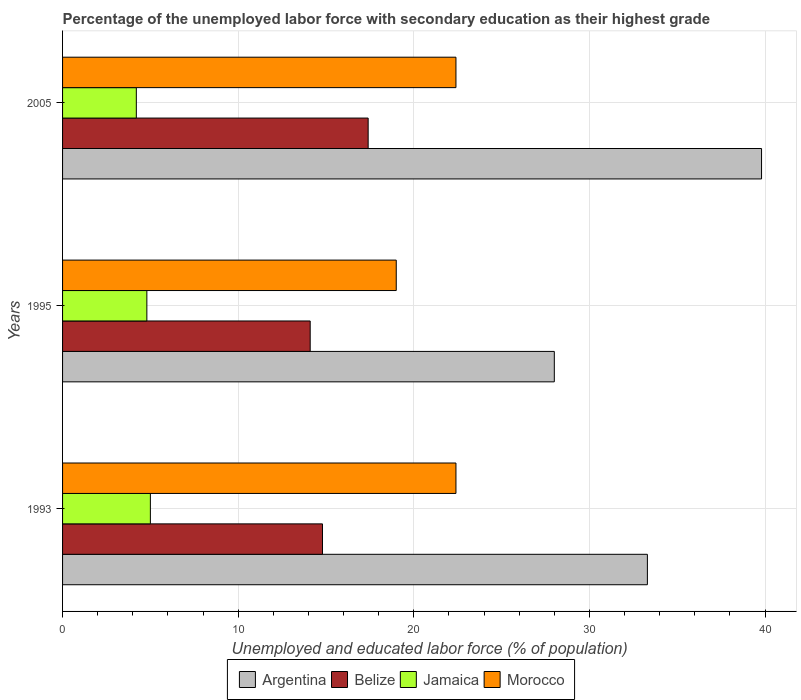How many different coloured bars are there?
Your answer should be very brief. 4. How many groups of bars are there?
Your answer should be very brief. 3. In how many cases, is the number of bars for a given year not equal to the number of legend labels?
Offer a very short reply. 0. What is the percentage of the unemployed labor force with secondary education in Argentina in 2005?
Offer a very short reply. 39.8. Across all years, what is the maximum percentage of the unemployed labor force with secondary education in Argentina?
Your answer should be compact. 39.8. Across all years, what is the minimum percentage of the unemployed labor force with secondary education in Belize?
Provide a short and direct response. 14.1. In which year was the percentage of the unemployed labor force with secondary education in Morocco maximum?
Offer a terse response. 1993. What is the total percentage of the unemployed labor force with secondary education in Morocco in the graph?
Give a very brief answer. 63.8. What is the difference between the percentage of the unemployed labor force with secondary education in Belize in 1995 and that in 2005?
Your answer should be very brief. -3.3. What is the difference between the percentage of the unemployed labor force with secondary education in Jamaica in 1993 and the percentage of the unemployed labor force with secondary education in Belize in 1995?
Ensure brevity in your answer.  -9.1. What is the average percentage of the unemployed labor force with secondary education in Jamaica per year?
Your response must be concise. 4.67. In the year 1993, what is the difference between the percentage of the unemployed labor force with secondary education in Jamaica and percentage of the unemployed labor force with secondary education in Morocco?
Give a very brief answer. -17.4. What is the difference between the highest and the second highest percentage of the unemployed labor force with secondary education in Jamaica?
Keep it short and to the point. 0.2. What is the difference between the highest and the lowest percentage of the unemployed labor force with secondary education in Belize?
Your answer should be very brief. 3.3. In how many years, is the percentage of the unemployed labor force with secondary education in Argentina greater than the average percentage of the unemployed labor force with secondary education in Argentina taken over all years?
Provide a short and direct response. 1. Is the sum of the percentage of the unemployed labor force with secondary education in Belize in 1993 and 1995 greater than the maximum percentage of the unemployed labor force with secondary education in Argentina across all years?
Give a very brief answer. No. Is it the case that in every year, the sum of the percentage of the unemployed labor force with secondary education in Morocco and percentage of the unemployed labor force with secondary education in Belize is greater than the sum of percentage of the unemployed labor force with secondary education in Jamaica and percentage of the unemployed labor force with secondary education in Argentina?
Provide a short and direct response. No. What does the 3rd bar from the top in 2005 represents?
Offer a very short reply. Belize. What does the 3rd bar from the bottom in 2005 represents?
Offer a very short reply. Jamaica. Is it the case that in every year, the sum of the percentage of the unemployed labor force with secondary education in Morocco and percentage of the unemployed labor force with secondary education in Belize is greater than the percentage of the unemployed labor force with secondary education in Argentina?
Offer a very short reply. Yes. How many years are there in the graph?
Provide a short and direct response. 3. What is the difference between two consecutive major ticks on the X-axis?
Offer a terse response. 10. What is the title of the graph?
Your response must be concise. Percentage of the unemployed labor force with secondary education as their highest grade. Does "Mongolia" appear as one of the legend labels in the graph?
Keep it short and to the point. No. What is the label or title of the X-axis?
Your answer should be compact. Unemployed and educated labor force (% of population). What is the Unemployed and educated labor force (% of population) of Argentina in 1993?
Keep it short and to the point. 33.3. What is the Unemployed and educated labor force (% of population) of Belize in 1993?
Provide a succinct answer. 14.8. What is the Unemployed and educated labor force (% of population) in Jamaica in 1993?
Make the answer very short. 5. What is the Unemployed and educated labor force (% of population) of Morocco in 1993?
Offer a terse response. 22.4. What is the Unemployed and educated labor force (% of population) in Argentina in 1995?
Your answer should be very brief. 28. What is the Unemployed and educated labor force (% of population) of Belize in 1995?
Give a very brief answer. 14.1. What is the Unemployed and educated labor force (% of population) in Jamaica in 1995?
Ensure brevity in your answer.  4.8. What is the Unemployed and educated labor force (% of population) in Morocco in 1995?
Give a very brief answer. 19. What is the Unemployed and educated labor force (% of population) of Argentina in 2005?
Give a very brief answer. 39.8. What is the Unemployed and educated labor force (% of population) in Belize in 2005?
Provide a succinct answer. 17.4. What is the Unemployed and educated labor force (% of population) in Jamaica in 2005?
Your answer should be compact. 4.2. What is the Unemployed and educated labor force (% of population) in Morocco in 2005?
Keep it short and to the point. 22.4. Across all years, what is the maximum Unemployed and educated labor force (% of population) in Argentina?
Provide a succinct answer. 39.8. Across all years, what is the maximum Unemployed and educated labor force (% of population) of Belize?
Offer a terse response. 17.4. Across all years, what is the maximum Unemployed and educated labor force (% of population) of Jamaica?
Ensure brevity in your answer.  5. Across all years, what is the maximum Unemployed and educated labor force (% of population) in Morocco?
Provide a succinct answer. 22.4. Across all years, what is the minimum Unemployed and educated labor force (% of population) of Argentina?
Ensure brevity in your answer.  28. Across all years, what is the minimum Unemployed and educated labor force (% of population) in Belize?
Provide a short and direct response. 14.1. Across all years, what is the minimum Unemployed and educated labor force (% of population) of Jamaica?
Keep it short and to the point. 4.2. Across all years, what is the minimum Unemployed and educated labor force (% of population) of Morocco?
Provide a short and direct response. 19. What is the total Unemployed and educated labor force (% of population) of Argentina in the graph?
Make the answer very short. 101.1. What is the total Unemployed and educated labor force (% of population) in Belize in the graph?
Offer a very short reply. 46.3. What is the total Unemployed and educated labor force (% of population) of Morocco in the graph?
Offer a terse response. 63.8. What is the difference between the Unemployed and educated labor force (% of population) of Argentina in 1993 and that in 1995?
Make the answer very short. 5.3. What is the difference between the Unemployed and educated labor force (% of population) of Argentina in 1993 and that in 2005?
Provide a succinct answer. -6.5. What is the difference between the Unemployed and educated labor force (% of population) in Belize in 1993 and that in 2005?
Offer a terse response. -2.6. What is the difference between the Unemployed and educated labor force (% of population) of Belize in 1995 and that in 2005?
Make the answer very short. -3.3. What is the difference between the Unemployed and educated labor force (% of population) in Jamaica in 1995 and that in 2005?
Make the answer very short. 0.6. What is the difference between the Unemployed and educated labor force (% of population) in Morocco in 1995 and that in 2005?
Your answer should be compact. -3.4. What is the difference between the Unemployed and educated labor force (% of population) in Argentina in 1993 and the Unemployed and educated labor force (% of population) in Belize in 1995?
Your answer should be very brief. 19.2. What is the difference between the Unemployed and educated labor force (% of population) in Argentina in 1993 and the Unemployed and educated labor force (% of population) in Jamaica in 1995?
Give a very brief answer. 28.5. What is the difference between the Unemployed and educated labor force (% of population) in Belize in 1993 and the Unemployed and educated labor force (% of population) in Morocco in 1995?
Provide a short and direct response. -4.2. What is the difference between the Unemployed and educated labor force (% of population) in Jamaica in 1993 and the Unemployed and educated labor force (% of population) in Morocco in 1995?
Your answer should be very brief. -14. What is the difference between the Unemployed and educated labor force (% of population) in Argentina in 1993 and the Unemployed and educated labor force (% of population) in Belize in 2005?
Offer a very short reply. 15.9. What is the difference between the Unemployed and educated labor force (% of population) of Argentina in 1993 and the Unemployed and educated labor force (% of population) of Jamaica in 2005?
Your answer should be compact. 29.1. What is the difference between the Unemployed and educated labor force (% of population) of Belize in 1993 and the Unemployed and educated labor force (% of population) of Morocco in 2005?
Your response must be concise. -7.6. What is the difference between the Unemployed and educated labor force (% of population) of Jamaica in 1993 and the Unemployed and educated labor force (% of population) of Morocco in 2005?
Offer a terse response. -17.4. What is the difference between the Unemployed and educated labor force (% of population) of Argentina in 1995 and the Unemployed and educated labor force (% of population) of Belize in 2005?
Your answer should be very brief. 10.6. What is the difference between the Unemployed and educated labor force (% of population) in Argentina in 1995 and the Unemployed and educated labor force (% of population) in Jamaica in 2005?
Offer a very short reply. 23.8. What is the difference between the Unemployed and educated labor force (% of population) of Argentina in 1995 and the Unemployed and educated labor force (% of population) of Morocco in 2005?
Give a very brief answer. 5.6. What is the difference between the Unemployed and educated labor force (% of population) of Belize in 1995 and the Unemployed and educated labor force (% of population) of Jamaica in 2005?
Provide a short and direct response. 9.9. What is the difference between the Unemployed and educated labor force (% of population) in Jamaica in 1995 and the Unemployed and educated labor force (% of population) in Morocco in 2005?
Provide a short and direct response. -17.6. What is the average Unemployed and educated labor force (% of population) in Argentina per year?
Provide a short and direct response. 33.7. What is the average Unemployed and educated labor force (% of population) in Belize per year?
Your answer should be very brief. 15.43. What is the average Unemployed and educated labor force (% of population) in Jamaica per year?
Your answer should be very brief. 4.67. What is the average Unemployed and educated labor force (% of population) in Morocco per year?
Give a very brief answer. 21.27. In the year 1993, what is the difference between the Unemployed and educated labor force (% of population) of Argentina and Unemployed and educated labor force (% of population) of Jamaica?
Offer a terse response. 28.3. In the year 1993, what is the difference between the Unemployed and educated labor force (% of population) in Belize and Unemployed and educated labor force (% of population) in Jamaica?
Provide a short and direct response. 9.8. In the year 1993, what is the difference between the Unemployed and educated labor force (% of population) in Jamaica and Unemployed and educated labor force (% of population) in Morocco?
Give a very brief answer. -17.4. In the year 1995, what is the difference between the Unemployed and educated labor force (% of population) in Argentina and Unemployed and educated labor force (% of population) in Jamaica?
Provide a short and direct response. 23.2. In the year 1995, what is the difference between the Unemployed and educated labor force (% of population) in Belize and Unemployed and educated labor force (% of population) in Morocco?
Ensure brevity in your answer.  -4.9. In the year 2005, what is the difference between the Unemployed and educated labor force (% of population) of Argentina and Unemployed and educated labor force (% of population) of Belize?
Your answer should be compact. 22.4. In the year 2005, what is the difference between the Unemployed and educated labor force (% of population) of Argentina and Unemployed and educated labor force (% of population) of Jamaica?
Provide a succinct answer. 35.6. In the year 2005, what is the difference between the Unemployed and educated labor force (% of population) of Argentina and Unemployed and educated labor force (% of population) of Morocco?
Ensure brevity in your answer.  17.4. In the year 2005, what is the difference between the Unemployed and educated labor force (% of population) in Belize and Unemployed and educated labor force (% of population) in Jamaica?
Offer a terse response. 13.2. In the year 2005, what is the difference between the Unemployed and educated labor force (% of population) of Jamaica and Unemployed and educated labor force (% of population) of Morocco?
Your answer should be compact. -18.2. What is the ratio of the Unemployed and educated labor force (% of population) in Argentina in 1993 to that in 1995?
Provide a succinct answer. 1.19. What is the ratio of the Unemployed and educated labor force (% of population) of Belize in 1993 to that in 1995?
Ensure brevity in your answer.  1.05. What is the ratio of the Unemployed and educated labor force (% of population) in Jamaica in 1993 to that in 1995?
Make the answer very short. 1.04. What is the ratio of the Unemployed and educated labor force (% of population) in Morocco in 1993 to that in 1995?
Your response must be concise. 1.18. What is the ratio of the Unemployed and educated labor force (% of population) in Argentina in 1993 to that in 2005?
Provide a short and direct response. 0.84. What is the ratio of the Unemployed and educated labor force (% of population) of Belize in 1993 to that in 2005?
Provide a short and direct response. 0.85. What is the ratio of the Unemployed and educated labor force (% of population) in Jamaica in 1993 to that in 2005?
Your answer should be very brief. 1.19. What is the ratio of the Unemployed and educated labor force (% of population) of Morocco in 1993 to that in 2005?
Your response must be concise. 1. What is the ratio of the Unemployed and educated labor force (% of population) in Argentina in 1995 to that in 2005?
Your answer should be very brief. 0.7. What is the ratio of the Unemployed and educated labor force (% of population) in Belize in 1995 to that in 2005?
Provide a short and direct response. 0.81. What is the ratio of the Unemployed and educated labor force (% of population) of Morocco in 1995 to that in 2005?
Provide a short and direct response. 0.85. What is the difference between the highest and the second highest Unemployed and educated labor force (% of population) of Jamaica?
Make the answer very short. 0.2. What is the difference between the highest and the second highest Unemployed and educated labor force (% of population) of Morocco?
Make the answer very short. 0. What is the difference between the highest and the lowest Unemployed and educated labor force (% of population) in Argentina?
Your response must be concise. 11.8. What is the difference between the highest and the lowest Unemployed and educated labor force (% of population) in Belize?
Your response must be concise. 3.3. What is the difference between the highest and the lowest Unemployed and educated labor force (% of population) of Jamaica?
Make the answer very short. 0.8. What is the difference between the highest and the lowest Unemployed and educated labor force (% of population) of Morocco?
Keep it short and to the point. 3.4. 